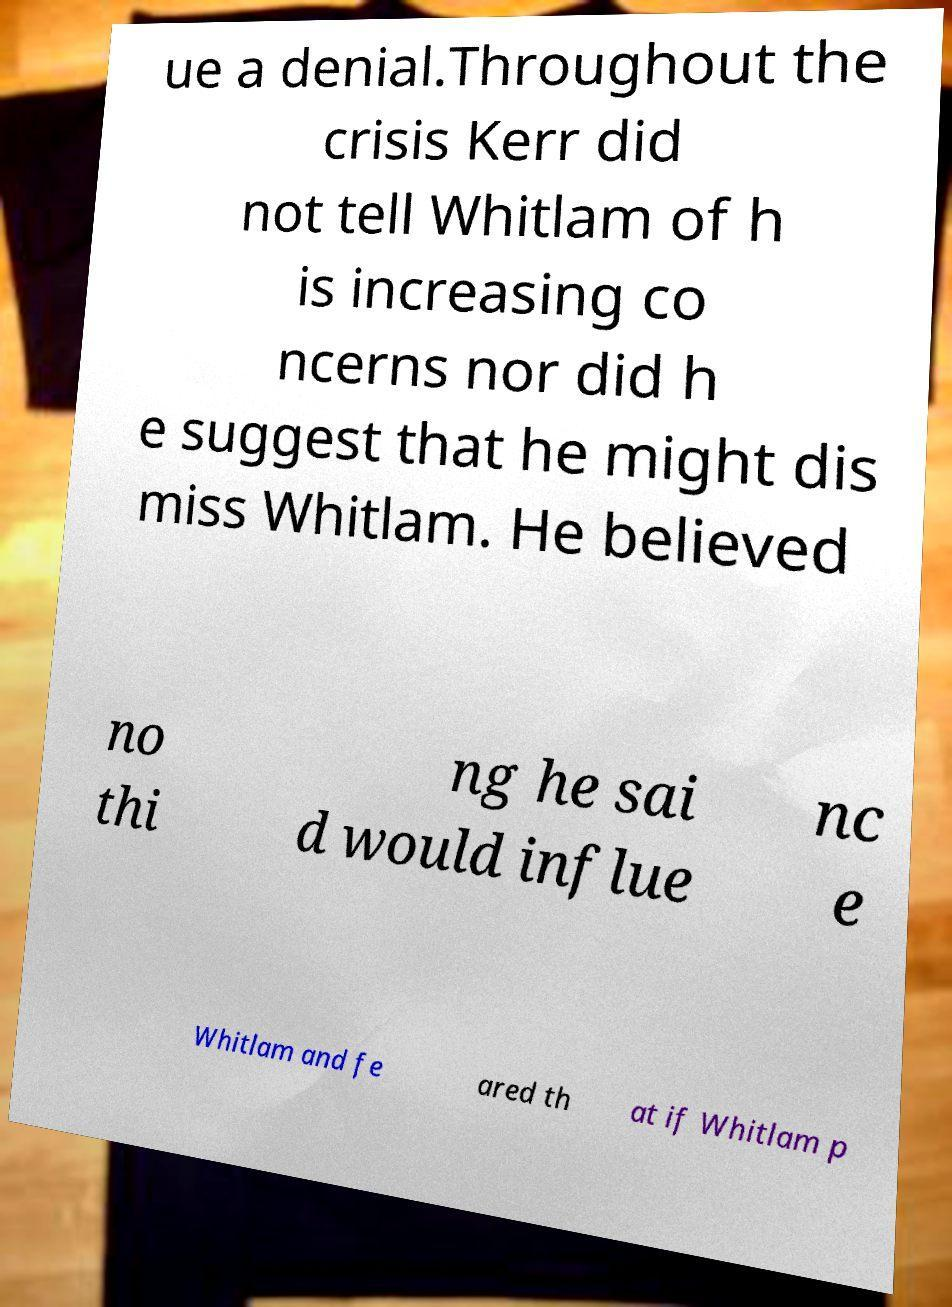Can you accurately transcribe the text from the provided image for me? ue a denial.Throughout the crisis Kerr did not tell Whitlam of h is increasing co ncerns nor did h e suggest that he might dis miss Whitlam. He believed no thi ng he sai d would influe nc e Whitlam and fe ared th at if Whitlam p 